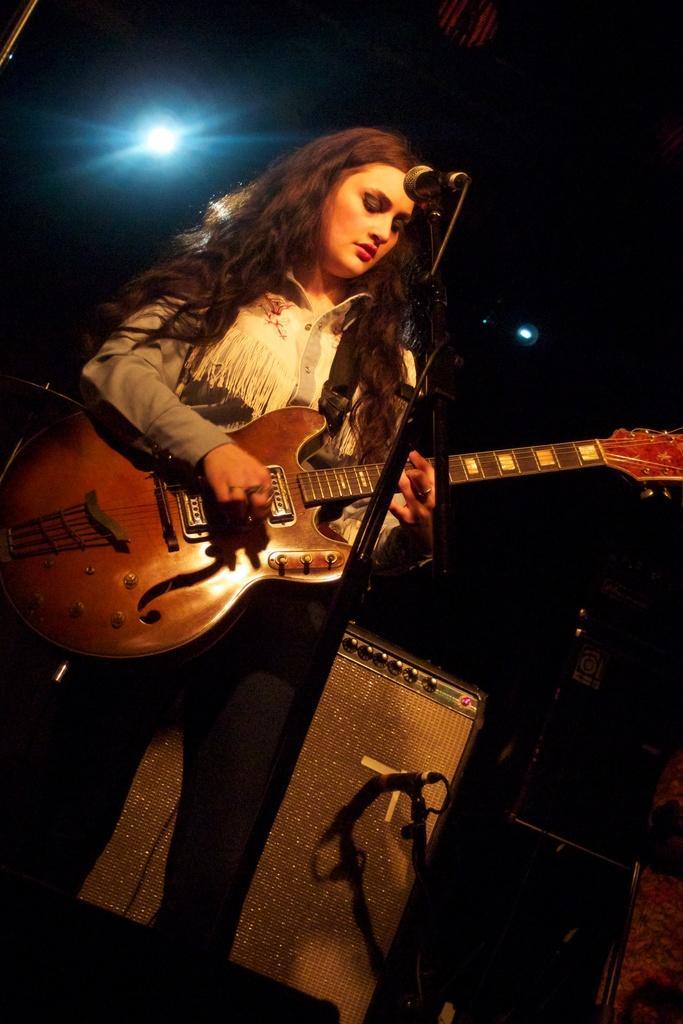In one or two sentences, can you explain what this image depicts? In this picture we can see a lady who is holding a guitar and playing it in front of the mic and behind her there are musical instruments and a light. 